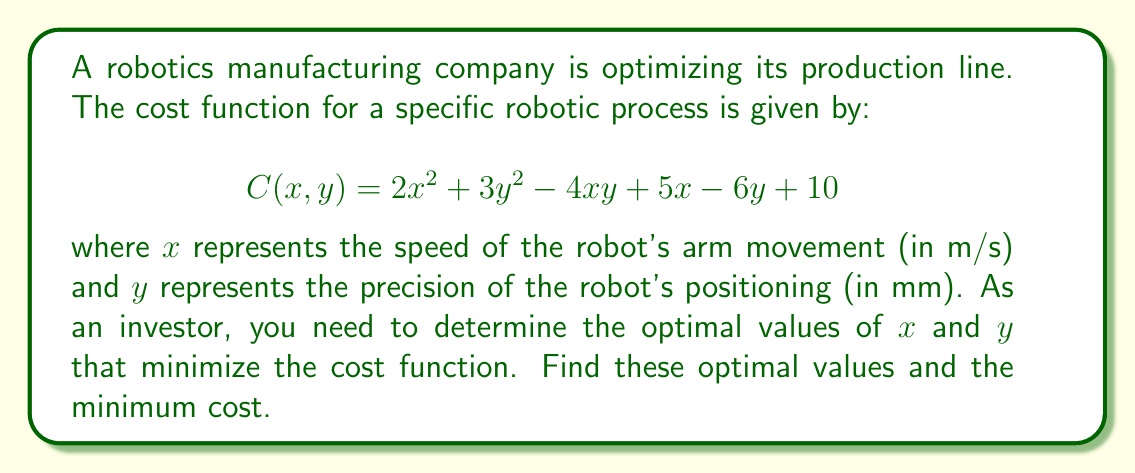Can you answer this question? To find the optimal values of $x$ and $y$ that minimize the cost function, we need to follow these steps:

1. Calculate the partial derivatives of $C(x, y)$ with respect to $x$ and $y$:

   $$\frac{\partial C}{\partial x} = 4x - 4y + 5$$
   $$\frac{\partial C}{\partial y} = 6y - 4x - 6$$

2. Set both partial derivatives to zero to find the critical points:

   $$4x - 4y + 5 = 0 \quad (1)$$
   $$6y - 4x - 6 = 0 \quad (2)$$

3. Solve the system of equations:
   From equation (2): $y = \frac{2x + 3}{3}$
   
   Substitute this into equation (1):
   $$4x - 4(\frac{2x + 3}{3}) + 5 = 0$$
   $$12x - 8x - 12 + 15 = 0$$
   $$4x + 3 = 0$$
   $$x = -\frac{3}{4}$$

   Substitute $x$ back into the equation for $y$:
   $$y = \frac{2(-\frac{3}{4}) + 3}{3} = \frac{1}{2}$$

4. Verify that this critical point is a minimum by checking the second derivatives:

   $$\frac{\partial^2 C}{\partial x^2} = 4 > 0$$
   $$\frac{\partial^2 C}{\partial y^2} = 6 > 0$$
   $$\frac{\partial^2 C}{\partial x \partial y} = -4$$

   The Hessian determinant is:
   $$H = \begin{vmatrix} 
   4 & -4 \\
   -4 & 6
   \end{vmatrix} = 24 - 16 = 8 > 0$$

   Since $\frac{\partial^2 C}{\partial x^2} > 0$ and $H > 0$, the critical point is a minimum.

5. Calculate the minimum cost by substituting the optimal $x$ and $y$ values into the original cost function:

   $$C(-\frac{3}{4}, \frac{1}{2}) = 2(-\frac{3}{4})^2 + 3(\frac{1}{2})^2 - 4(-\frac{3}{4})(\frac{1}{2}) + 5(-\frac{3}{4}) - 6(\frac{1}{2}) + 10$$
   $$= \frac{9}{8} + \frac{3}{4} + \frac{3}{2} - \frac{15}{4} - 3 + 10$$
   $$= \frac{9}{8} + \frac{3}{4} + \frac{6}{4} - \frac{15}{4} - \frac{12}{4} + \frac{40}{4}$$
   $$= \frac{9}{8} + \frac{22}{4} = \frac{9}{8} + \frac{44}{8} = \frac{53}{8} = 6.625$$
Answer: Optimal values: $x = -\frac{3}{4}$, $y = \frac{1}{2}$; Minimum cost: $\frac{53}{8}$ or $6.625$ 